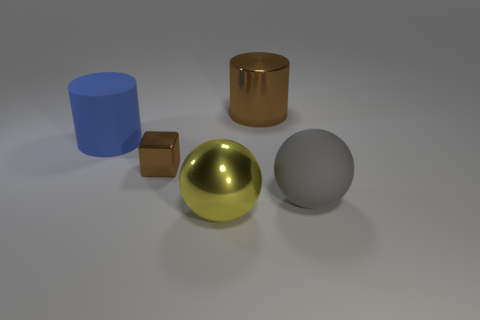Add 4 small brown metallic things. How many objects exist? 9 Subtract all cubes. How many objects are left? 4 Subtract 1 yellow balls. How many objects are left? 4 Subtract all large metallic balls. Subtract all small brown cubes. How many objects are left? 3 Add 5 cubes. How many cubes are left? 6 Add 4 large cyan objects. How many large cyan objects exist? 4 